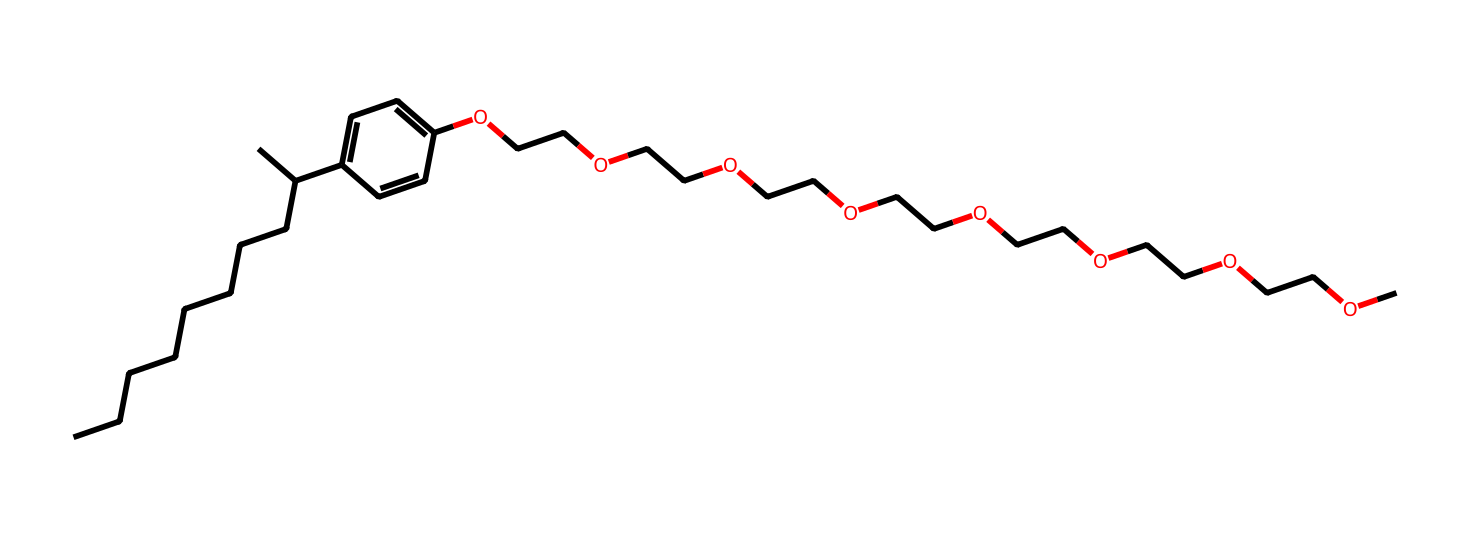how many carbon atoms are in this compound? Analyzing the SMILES representation reveals the presence of carbon atoms. The chain CCCCCCCCC(C) indicates 10 carbon atoms, and the aromatic ring C1=CC=C(C=C1) adds an additional 6 carbon atoms, making a total of 16 carbon atoms.
Answer: 16 what is the functional group present in this chemical? The presence of "OCC" segments in the structure indicates the presence of ether functional groups associated with the ethoxylate portion of the molecule. This confirms the existence of ether functional groups in the compound.
Answer: ether what is the number of ethylene oxide units in this structure? Counting the "OCC" segments indicates there are 7 ethylene oxide units in this molecule, as each segment corresponds to one ethylene oxide unit in the chain.
Answer: 7 what type of environmental concern is associated with nonylphenol ethoxylates? Nonylphenol ethoxylates are known to be endocrine disruptors, which can interfere with hormone function in wildlife and humans, posing significant environmental health risks.
Answer: endocrine disruptors how does the hydrophilic-lipophilic balance of this compound affect its surfactant properties? The presence of both a long hydrophobic alkyl chain (the nonyl group) and multiple hydrophilic ethylene oxide units create a favorable hydrophilic-lipophilic balance. This balance allows the compound to effectively lower surface tension and improve wetting properties, making it an effective surfactant.
Answer: effective surfactant what role does the aromatic ring play in the properties of the chemical? The aromatic ring contributes to the chemical's stability and hydrophobic characteristics, enhancing the surfactant's ability to interact with various organic pollutants and improve cleaning efficacy.
Answer: stability and hydrophobicity 